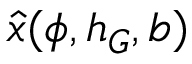Convert formula to latex. <formula><loc_0><loc_0><loc_500><loc_500>\hat { x } ( \phi , h _ { G } , b )</formula> 